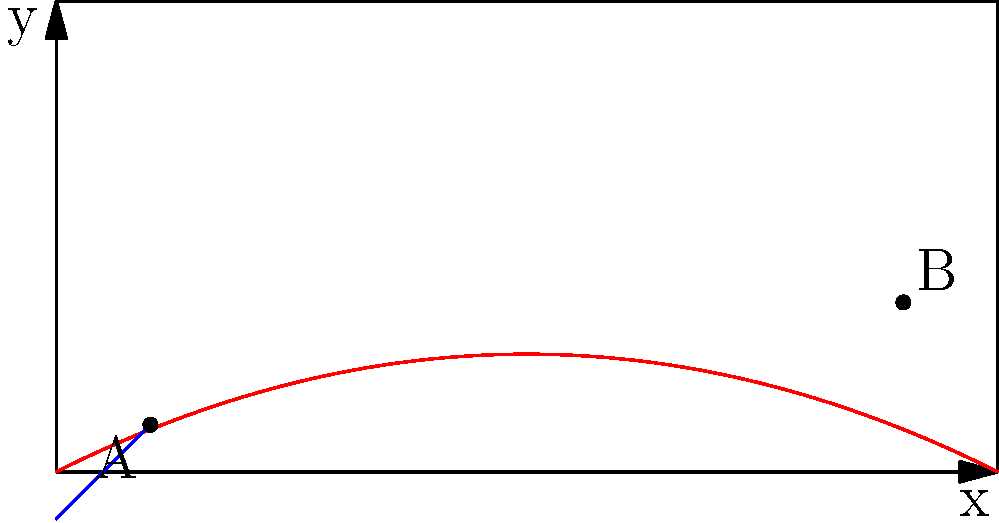A masse shot in pool involves striking the cue ball with an elevated cue stick to impart spin, causing the ball to follow a curved path. Given a cue angle of 30 degrees from the horizontal and a spin rate of 50 revolutions per second, calculate the maximum height reached by the cue ball if it travels a horizontal distance of 8 feet before reaching its peak. Assume the initial velocity of the cue ball is 10 feet per second and neglect air resistance. To solve this problem, we'll follow these steps:

1) The trajectory of a masse shot can be approximated by a parabola. The general equation for a parabola is:

   $$y = ax^2 + bx + c$$

   where $a$, $b$, and $c$ are constants.

2) We know that the ball starts at the origin (0,0), so $c = 0$.

3) The initial velocity components are:
   $$v_x = v \cos(\theta) = 10 \cos(30°) = 8.66 \text{ ft/s}$$
   $$v_y = v \sin(\theta) = 10 \sin(30°) = 5 \text{ ft/s}$$

4) The time to reach the peak height is:
   $$t = \frac{v_y}{g} = \frac{5}{32} = 0.15625 \text{ s}$$

5) The horizontal distance traveled in this time is:
   $$x = v_x t = 8.66 * 0.15625 = 1.35 \text{ ft}$$

6) We're given that the peak occurs at 8 ft horizontally. To account for the spin effect, we need to adjust our parabola. Let's say the spin causes the peak to occur later, at 8 ft instead of 1.35 ft.

7) We can now form two equations:
   At x = 0: $y = 0$
   At x = 8: $\frac{dy}{dx} = 0$ (peak of parabola)

8) The second condition gives us:
   $$\frac{dy}{dx} = 2ax + b = 0 \text{ at } x = 8$$
   $$16a + b = 0$$

9) Substituting back into the original equation:
   $$y = ax^2 + bx = ax^2 - 16ax = ax(x-16)$$

10) To find $a$, we can use the fact that the ball rises 5 ft in 1.35 ft horizontally without spin:
    $$5 = a(1.35)(1.35-16)$$
    $$a = -0.254$$

11) Now we can find the maximum height:
    $$y_{max} = a(8)(8-16) = -0.254 * 8 * -8 = 16.256 \text{ ft}$$
Answer: 16.26 feet 